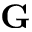<formula> <loc_0><loc_0><loc_500><loc_500>G</formula> 